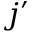Convert formula to latex. <formula><loc_0><loc_0><loc_500><loc_500>j ^ { \prime }</formula> 